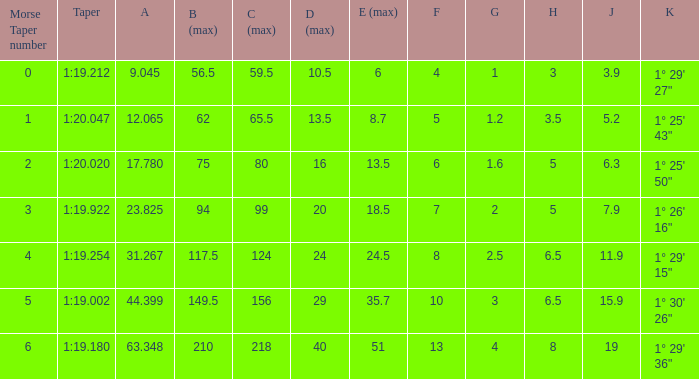04 1.0. 